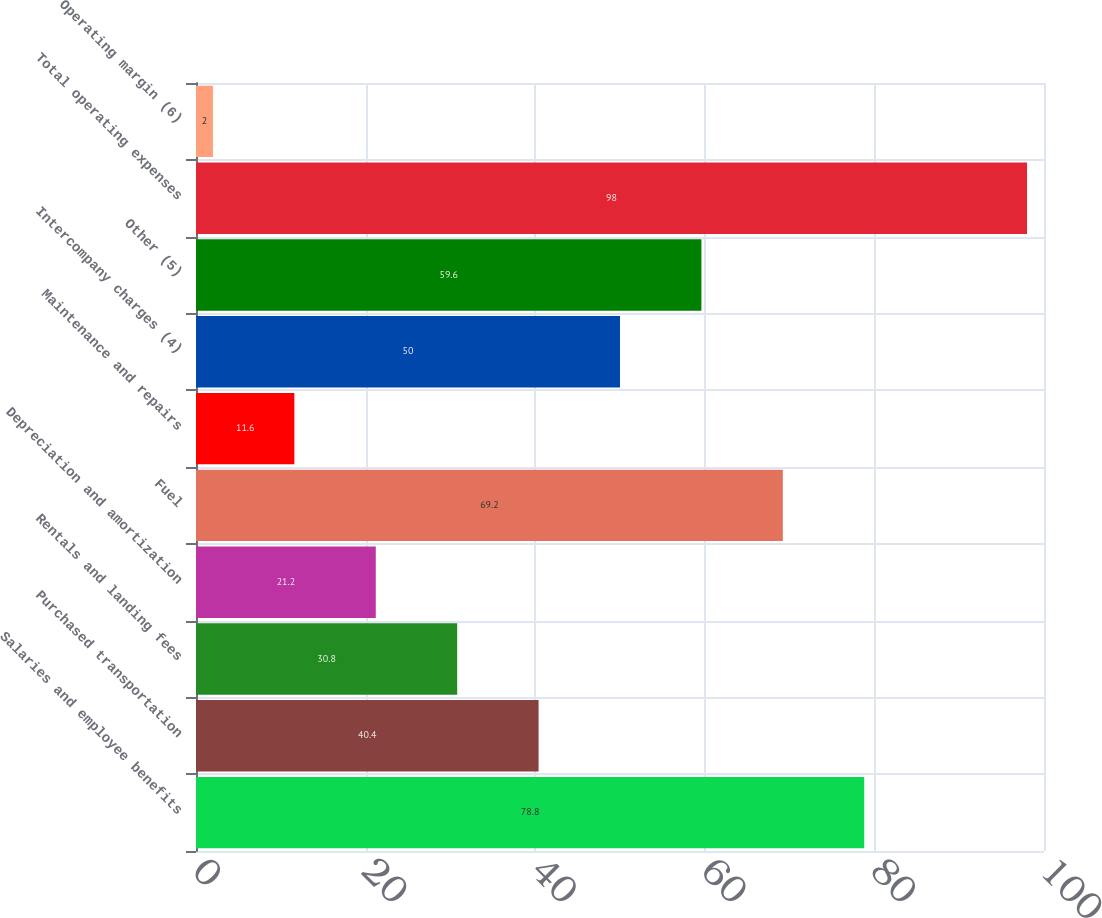Convert chart to OTSL. <chart><loc_0><loc_0><loc_500><loc_500><bar_chart><fcel>Salaries and employee benefits<fcel>Purchased transportation<fcel>Rentals and landing fees<fcel>Depreciation and amortization<fcel>Fuel<fcel>Maintenance and repairs<fcel>Intercompany charges (4)<fcel>Other (5)<fcel>Total operating expenses<fcel>Operating margin (6)<nl><fcel>78.8<fcel>40.4<fcel>30.8<fcel>21.2<fcel>69.2<fcel>11.6<fcel>50<fcel>59.6<fcel>98<fcel>2<nl></chart> 